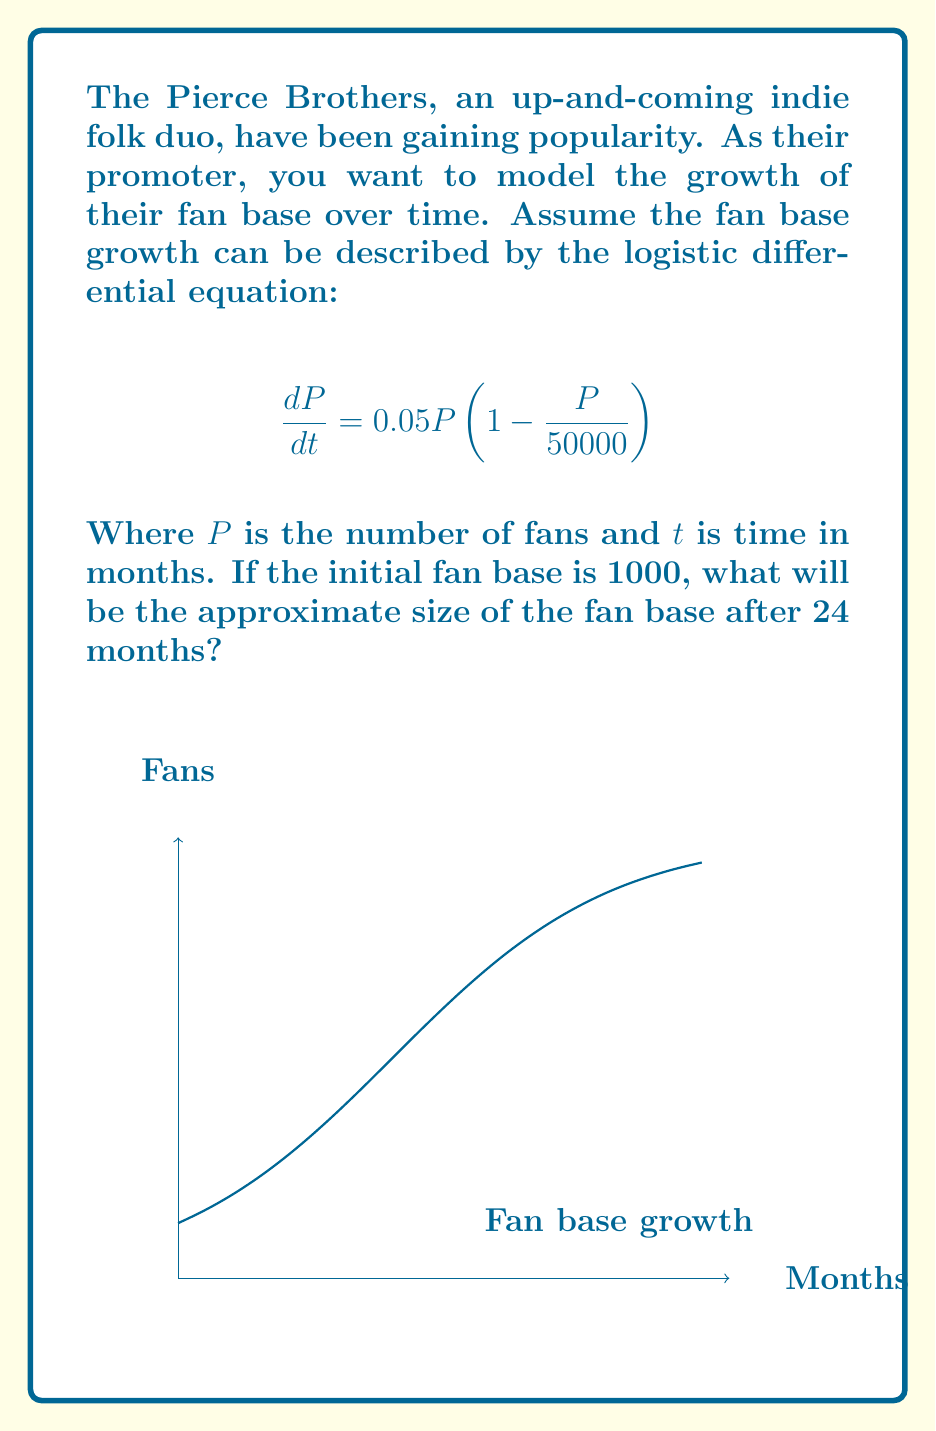Can you solve this math problem? To solve this problem, we need to use the solution to the logistic differential equation:

1) The general solution to the logistic equation $\frac{dP}{dt} = rP(1 - \frac{P}{K})$ is:

   $$P(t) = \frac{K}{1 + (\frac{K}{P_0} - 1)e^{-rt}}$$

   Where $K$ is the carrying capacity, $r$ is the growth rate, and $P_0$ is the initial population.

2) In our case, $K = 50000$, $r = 0.05$, and $P_0 = 1000$.

3) Substituting these values into the solution:

   $$P(t) = \frac{50000}{1 + (\frac{50000}{1000} - 1)e^{-0.05t}}$$

4) Simplify:

   $$P(t) = \frac{50000}{1 + 49e^{-0.05t}}$$

5) We want to find $P(24)$, so let's substitute $t = 24$:

   $$P(24) = \frac{50000}{1 + 49e^{-0.05(24)}}$$

6) Calculate:

   $$P(24) = \frac{50000}{1 + 49e^{-1.2}} \approx 13,534$$

Therefore, after 24 months, the fan base will be approximately 13,534 fans.
Answer: 13,534 fans 